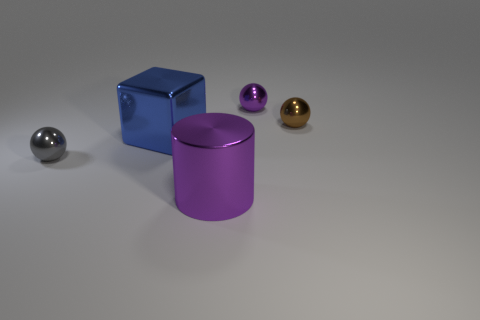Subtract 1 balls. How many balls are left? 2 Add 3 large blue cubes. How many objects exist? 8 Subtract all cyan spheres. Subtract all red cylinders. How many spheres are left? 3 Subtract all blocks. How many objects are left? 4 Subtract 0 blue balls. How many objects are left? 5 Subtract all tiny red objects. Subtract all big blue metallic blocks. How many objects are left? 4 Add 5 tiny purple metal things. How many tiny purple metal things are left? 6 Add 1 brown rubber objects. How many brown rubber objects exist? 1 